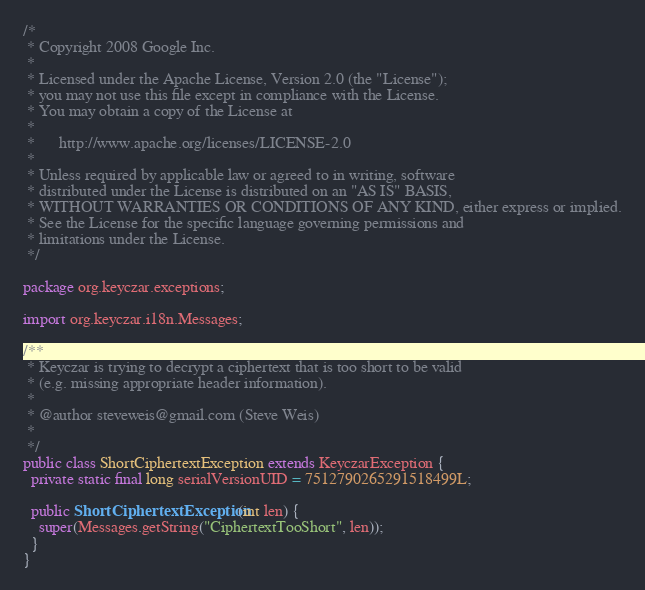<code> <loc_0><loc_0><loc_500><loc_500><_Java_>/*
 * Copyright 2008 Google Inc.
 *
 * Licensed under the Apache License, Version 2.0 (the "License");
 * you may not use this file except in compliance with the License.
 * You may obtain a copy of the License at
 *
 *      http://www.apache.org/licenses/LICENSE-2.0
 *
 * Unless required by applicable law or agreed to in writing, software
 * distributed under the License is distributed on an "AS IS" BASIS,
 * WITHOUT WARRANTIES OR CONDITIONS OF ANY KIND, either express or implied.
 * See the License for the specific language governing permissions and
 * limitations under the License.
 */

package org.keyczar.exceptions;

import org.keyczar.i18n.Messages;

/**
 * Keyczar is trying to decrypt a ciphertext that is too short to be valid
 * (e.g. missing appropriate header information).
 *
 * @author steveweis@gmail.com (Steve Weis)
 *
 */
public class ShortCiphertextException extends KeyczarException {
  private static final long serialVersionUID = 7512790265291518499L;

  public ShortCiphertextException(int len) {
    super(Messages.getString("CiphertextTooShort", len));
  }
}</code> 